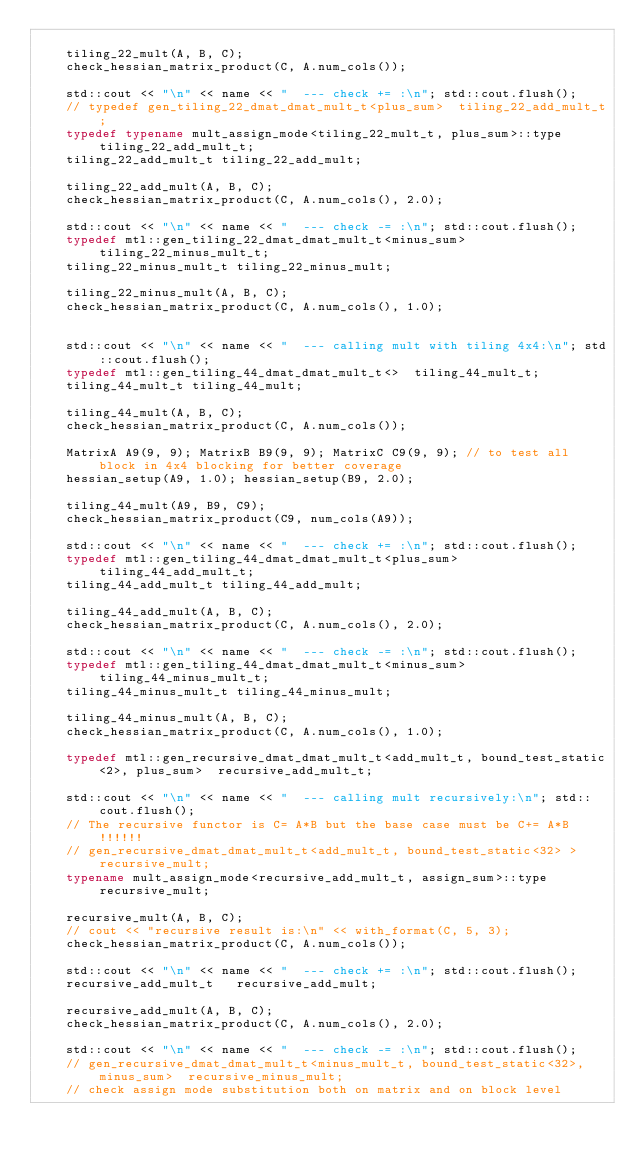<code> <loc_0><loc_0><loc_500><loc_500><_C++_>
    tiling_22_mult(A, B, C);
    check_hessian_matrix_product(C, A.num_cols()); 

    std::cout << "\n" << name << "  --- check += :\n"; std::cout.flush();
    // typedef gen_tiling_22_dmat_dmat_mult_t<plus_sum>  tiling_22_add_mult_t;
    typedef typename mult_assign_mode<tiling_22_mult_t, plus_sum>::type   tiling_22_add_mult_t;
    tiling_22_add_mult_t tiling_22_add_mult;

    tiling_22_add_mult(A, B, C); 
    check_hessian_matrix_product(C, A.num_cols(), 2.0);
    
    std::cout << "\n" << name << "  --- check -= :\n"; std::cout.flush();
    typedef mtl::gen_tiling_22_dmat_dmat_mult_t<minus_sum>  tiling_22_minus_mult_t;
    tiling_22_minus_mult_t tiling_22_minus_mult;

    tiling_22_minus_mult(A, B, C);
    check_hessian_matrix_product(C, A.num_cols(), 1.0);


    std::cout << "\n" << name << "  --- calling mult with tiling 4x4:\n"; std::cout.flush();
    typedef mtl::gen_tiling_44_dmat_dmat_mult_t<>  tiling_44_mult_t;
    tiling_44_mult_t tiling_44_mult;

    tiling_44_mult(A, B, C);
    check_hessian_matrix_product(C, A.num_cols()); 

    MatrixA A9(9, 9); MatrixB B9(9, 9); MatrixC C9(9, 9); // to test all block in 4x4 blocking for better coverage
    hessian_setup(A9, 1.0); hessian_setup(B9, 2.0);

    tiling_44_mult(A9, B9, C9);
    check_hessian_matrix_product(C9, num_cols(A9)); 

    std::cout << "\n" << name << "  --- check += :\n"; std::cout.flush();
    typedef mtl::gen_tiling_44_dmat_dmat_mult_t<plus_sum>  tiling_44_add_mult_t;
    tiling_44_add_mult_t tiling_44_add_mult;

    tiling_44_add_mult(A, B, C); 
    check_hessian_matrix_product(C, A.num_cols(), 2.0);
    
    std::cout << "\n" << name << "  --- check -= :\n"; std::cout.flush();
    typedef mtl::gen_tiling_44_dmat_dmat_mult_t<minus_sum>  tiling_44_minus_mult_t;
    tiling_44_minus_mult_t tiling_44_minus_mult;

    tiling_44_minus_mult(A, B, C);
    check_hessian_matrix_product(C, A.num_cols(), 1.0);

    typedef mtl::gen_recursive_dmat_dmat_mult_t<add_mult_t, bound_test_static<2>, plus_sum>  recursive_add_mult_t;

    std::cout << "\n" << name << "  --- calling mult recursively:\n"; std::cout.flush();
    // The recursive functor is C= A*B but the base case must be C+= A*B !!!!!!
    // gen_recursive_dmat_dmat_mult_t<add_mult_t, bound_test_static<32> >  recursive_mult;
    typename mult_assign_mode<recursive_add_mult_t, assign_sum>::type	recursive_mult;

    recursive_mult(A, B, C);
    // cout << "recursive result is:\n" << with_format(C, 5, 3);
    check_hessian_matrix_product(C, A.num_cols()); 

    std::cout << "\n" << name << "  --- check += :\n"; std::cout.flush();
    recursive_add_mult_t   recursive_add_mult;

    recursive_add_mult(A, B, C); 
    check_hessian_matrix_product(C, A.num_cols(), 2.0);
    
    std::cout << "\n" << name << "  --- check -= :\n"; std::cout.flush();
    // gen_recursive_dmat_dmat_mult_t<minus_mult_t, bound_test_static<32>, minus_sum>  recursive_minus_mult; 
    // check assign mode substitution both on matrix and on block level</code> 